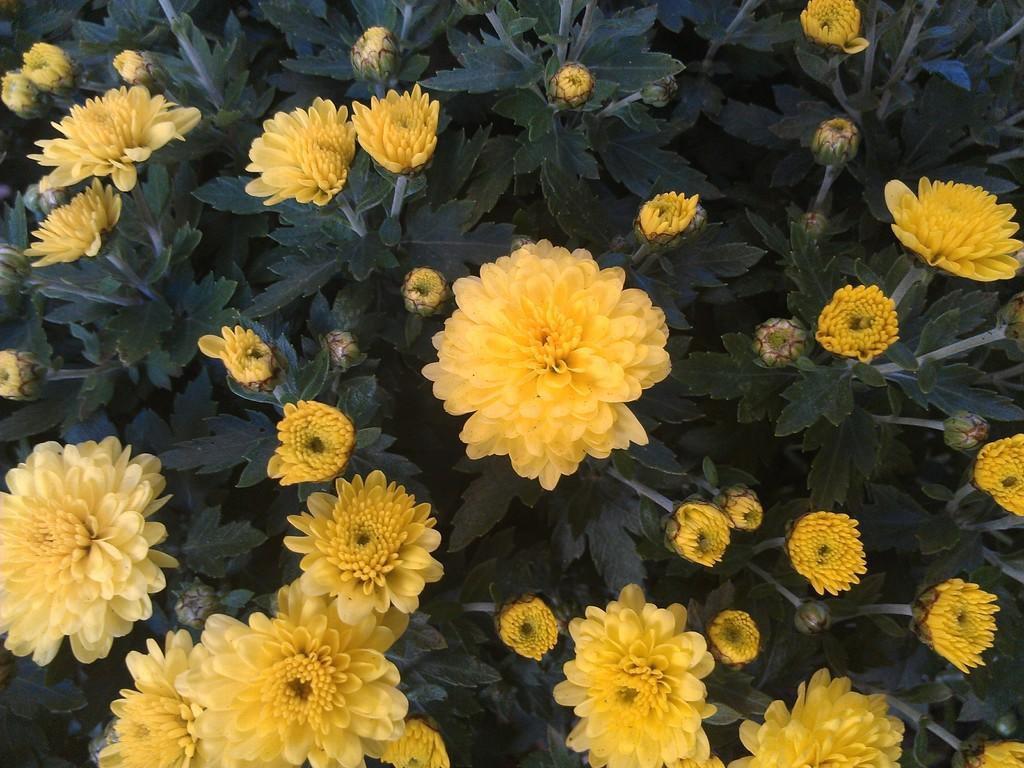Can you describe this image briefly? In this picture there are many yellow color flowers on the plant. 